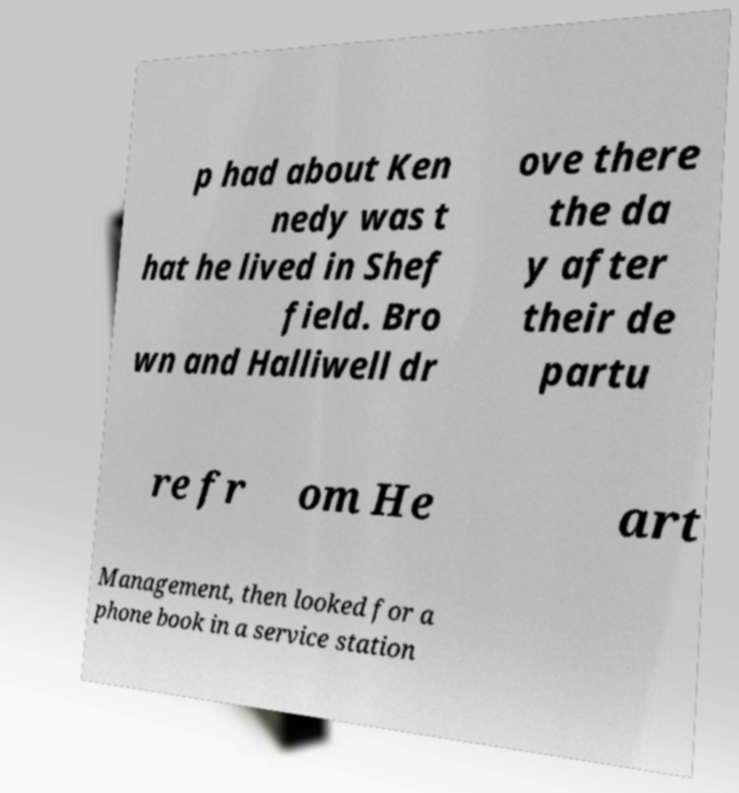Can you accurately transcribe the text from the provided image for me? p had about Ken nedy was t hat he lived in Shef field. Bro wn and Halliwell dr ove there the da y after their de partu re fr om He art Management, then looked for a phone book in a service station 